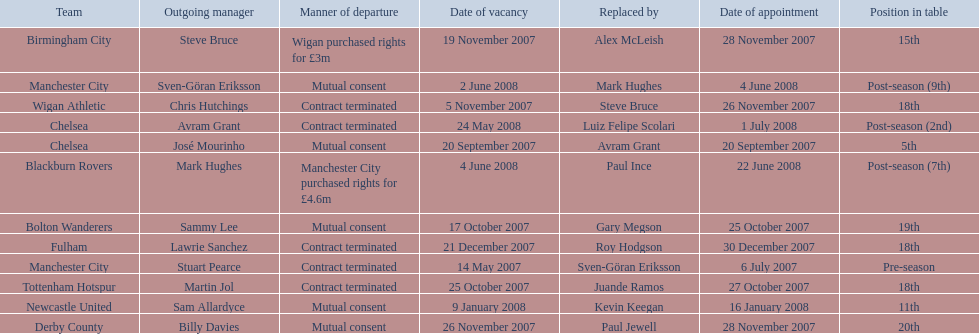Which outgoing manager was appointed the last? Mark Hughes. 